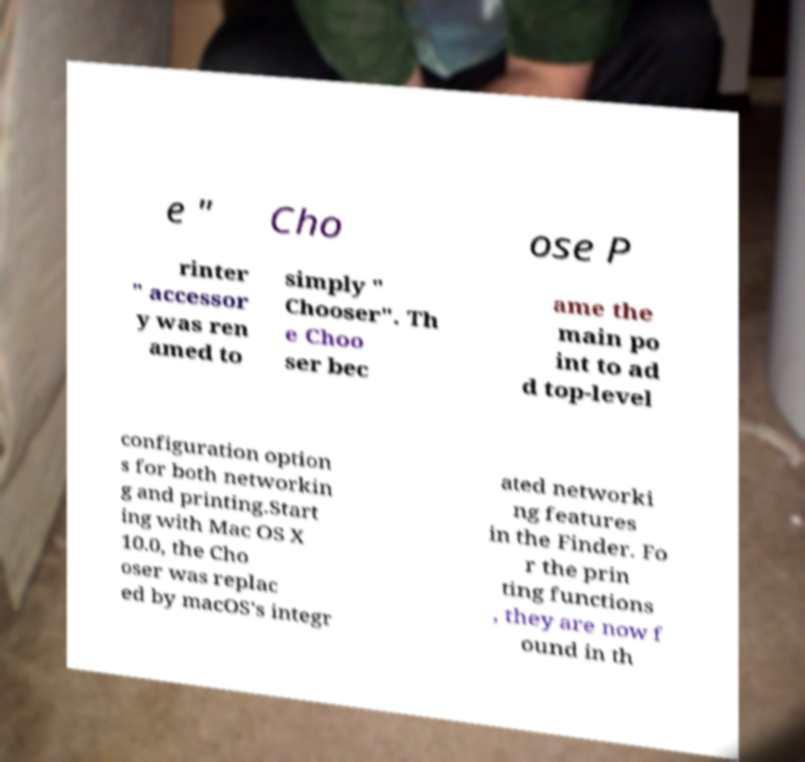Can you read and provide the text displayed in the image?This photo seems to have some interesting text. Can you extract and type it out for me? e " Cho ose P rinter " accessor y was ren amed to simply " Chooser". Th e Choo ser bec ame the main po int to ad d top-level configuration option s for both networkin g and printing.Start ing with Mac OS X 10.0, the Cho oser was replac ed by macOS's integr ated networki ng features in the Finder. Fo r the prin ting functions , they are now f ound in th 